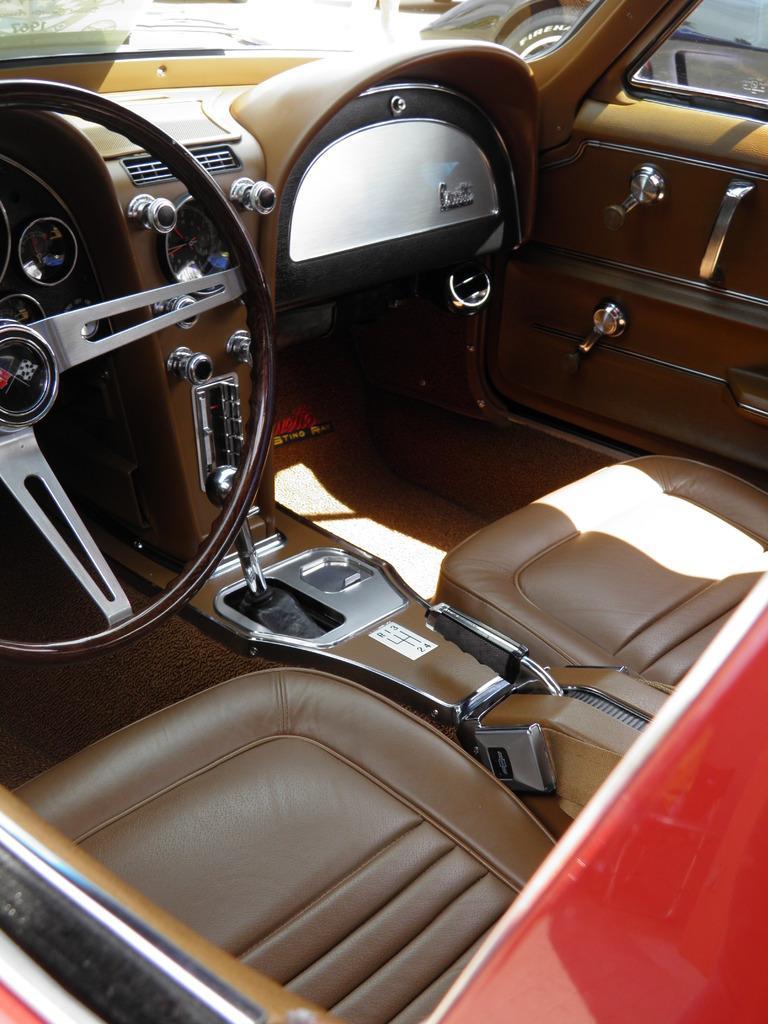Can you describe this image briefly? This picture might be taken inside the car. In this image, on the right side, we can see red color. On the left side, we can also see a steering. In the middle of the image, we can see a gear. In the background, we can see a glass window, out of the glass window, we can also see another car. 